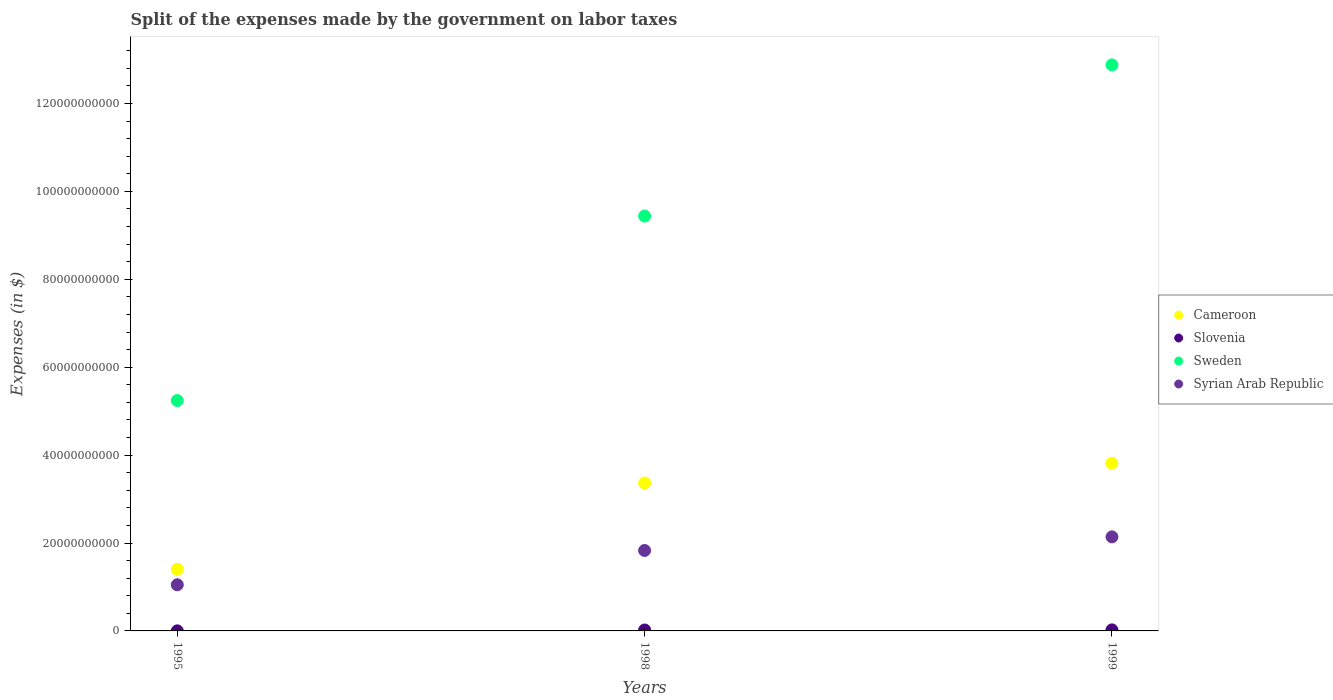How many different coloured dotlines are there?
Your answer should be compact. 4. Is the number of dotlines equal to the number of legend labels?
Your answer should be compact. Yes. What is the expenses made by the government on labor taxes in Cameroon in 1995?
Provide a succinct answer. 1.40e+1. Across all years, what is the maximum expenses made by the government on labor taxes in Cameroon?
Offer a terse response. 3.81e+1. Across all years, what is the minimum expenses made by the government on labor taxes in Cameroon?
Offer a terse response. 1.40e+1. In which year was the expenses made by the government on labor taxes in Slovenia maximum?
Make the answer very short. 1999. In which year was the expenses made by the government on labor taxes in Syrian Arab Republic minimum?
Ensure brevity in your answer.  1995. What is the total expenses made by the government on labor taxes in Slovenia in the graph?
Give a very brief answer. 4.68e+08. What is the difference between the expenses made by the government on labor taxes in Slovenia in 1995 and that in 1999?
Provide a short and direct response. -2.25e+08. What is the difference between the expenses made by the government on labor taxes in Slovenia in 1998 and the expenses made by the government on labor taxes in Sweden in 1999?
Your answer should be compact. -1.29e+11. What is the average expenses made by the government on labor taxes in Sweden per year?
Provide a short and direct response. 9.19e+1. In the year 1998, what is the difference between the expenses made by the government on labor taxes in Sweden and expenses made by the government on labor taxes in Cameroon?
Provide a short and direct response. 6.07e+1. What is the ratio of the expenses made by the government on labor taxes in Syrian Arab Republic in 1995 to that in 1998?
Provide a short and direct response. 0.57. What is the difference between the highest and the second highest expenses made by the government on labor taxes in Syrian Arab Republic?
Offer a very short reply. 3.10e+09. What is the difference between the highest and the lowest expenses made by the government on labor taxes in Sweden?
Offer a terse response. 7.64e+1. In how many years, is the expenses made by the government on labor taxes in Sweden greater than the average expenses made by the government on labor taxes in Sweden taken over all years?
Your answer should be compact. 2. Are the values on the major ticks of Y-axis written in scientific E-notation?
Ensure brevity in your answer.  No. Does the graph contain any zero values?
Your answer should be very brief. No. Does the graph contain grids?
Offer a very short reply. No. How are the legend labels stacked?
Your answer should be very brief. Vertical. What is the title of the graph?
Your answer should be compact. Split of the expenses made by the government on labor taxes. Does "Cabo Verde" appear as one of the legend labels in the graph?
Your answer should be compact. No. What is the label or title of the Y-axis?
Make the answer very short. Expenses (in $). What is the Expenses (in $) in Cameroon in 1995?
Your answer should be compact. 1.40e+1. What is the Expenses (in $) in Slovenia in 1995?
Keep it short and to the point. 1.59e+07. What is the Expenses (in $) in Sweden in 1995?
Offer a terse response. 5.24e+1. What is the Expenses (in $) in Syrian Arab Republic in 1995?
Keep it short and to the point. 1.05e+1. What is the Expenses (in $) of Cameroon in 1998?
Offer a terse response. 3.36e+1. What is the Expenses (in $) in Slovenia in 1998?
Offer a terse response. 2.12e+08. What is the Expenses (in $) of Sweden in 1998?
Your answer should be compact. 9.44e+1. What is the Expenses (in $) of Syrian Arab Republic in 1998?
Your answer should be compact. 1.83e+1. What is the Expenses (in $) of Cameroon in 1999?
Offer a very short reply. 3.81e+1. What is the Expenses (in $) of Slovenia in 1999?
Make the answer very short. 2.40e+08. What is the Expenses (in $) of Sweden in 1999?
Offer a very short reply. 1.29e+11. What is the Expenses (in $) in Syrian Arab Republic in 1999?
Your answer should be very brief. 2.14e+1. Across all years, what is the maximum Expenses (in $) of Cameroon?
Give a very brief answer. 3.81e+1. Across all years, what is the maximum Expenses (in $) of Slovenia?
Provide a short and direct response. 2.40e+08. Across all years, what is the maximum Expenses (in $) of Sweden?
Keep it short and to the point. 1.29e+11. Across all years, what is the maximum Expenses (in $) in Syrian Arab Republic?
Provide a succinct answer. 2.14e+1. Across all years, what is the minimum Expenses (in $) in Cameroon?
Give a very brief answer. 1.40e+1. Across all years, what is the minimum Expenses (in $) in Slovenia?
Keep it short and to the point. 1.59e+07. Across all years, what is the minimum Expenses (in $) of Sweden?
Offer a terse response. 5.24e+1. Across all years, what is the minimum Expenses (in $) in Syrian Arab Republic?
Keep it short and to the point. 1.05e+1. What is the total Expenses (in $) in Cameroon in the graph?
Give a very brief answer. 8.58e+1. What is the total Expenses (in $) in Slovenia in the graph?
Your response must be concise. 4.68e+08. What is the total Expenses (in $) of Sweden in the graph?
Ensure brevity in your answer.  2.76e+11. What is the total Expenses (in $) in Syrian Arab Republic in the graph?
Your answer should be compact. 5.02e+1. What is the difference between the Expenses (in $) of Cameroon in 1995 and that in 1998?
Provide a succinct answer. -1.96e+1. What is the difference between the Expenses (in $) in Slovenia in 1995 and that in 1998?
Offer a terse response. -1.96e+08. What is the difference between the Expenses (in $) of Sweden in 1995 and that in 1998?
Your answer should be very brief. -4.20e+1. What is the difference between the Expenses (in $) of Syrian Arab Republic in 1995 and that in 1998?
Your answer should be compact. -7.80e+09. What is the difference between the Expenses (in $) in Cameroon in 1995 and that in 1999?
Ensure brevity in your answer.  -2.41e+1. What is the difference between the Expenses (in $) in Slovenia in 1995 and that in 1999?
Your answer should be very brief. -2.25e+08. What is the difference between the Expenses (in $) in Sweden in 1995 and that in 1999?
Ensure brevity in your answer.  -7.64e+1. What is the difference between the Expenses (in $) in Syrian Arab Republic in 1995 and that in 1999?
Give a very brief answer. -1.09e+1. What is the difference between the Expenses (in $) of Cameroon in 1998 and that in 1999?
Offer a terse response. -4.49e+09. What is the difference between the Expenses (in $) of Slovenia in 1998 and that in 1999?
Your answer should be very brief. -2.88e+07. What is the difference between the Expenses (in $) of Sweden in 1998 and that in 1999?
Offer a terse response. -3.44e+1. What is the difference between the Expenses (in $) in Syrian Arab Republic in 1998 and that in 1999?
Provide a short and direct response. -3.10e+09. What is the difference between the Expenses (in $) in Cameroon in 1995 and the Expenses (in $) in Slovenia in 1998?
Provide a short and direct response. 1.38e+1. What is the difference between the Expenses (in $) of Cameroon in 1995 and the Expenses (in $) of Sweden in 1998?
Your response must be concise. -8.03e+1. What is the difference between the Expenses (in $) of Cameroon in 1995 and the Expenses (in $) of Syrian Arab Republic in 1998?
Offer a very short reply. -4.25e+09. What is the difference between the Expenses (in $) in Slovenia in 1995 and the Expenses (in $) in Sweden in 1998?
Make the answer very short. -9.44e+1. What is the difference between the Expenses (in $) in Slovenia in 1995 and the Expenses (in $) in Syrian Arab Republic in 1998?
Provide a short and direct response. -1.83e+1. What is the difference between the Expenses (in $) in Sweden in 1995 and the Expenses (in $) in Syrian Arab Republic in 1998?
Ensure brevity in your answer.  3.41e+1. What is the difference between the Expenses (in $) in Cameroon in 1995 and the Expenses (in $) in Slovenia in 1999?
Your response must be concise. 1.38e+1. What is the difference between the Expenses (in $) in Cameroon in 1995 and the Expenses (in $) in Sweden in 1999?
Ensure brevity in your answer.  -1.15e+11. What is the difference between the Expenses (in $) of Cameroon in 1995 and the Expenses (in $) of Syrian Arab Republic in 1999?
Offer a very short reply. -7.35e+09. What is the difference between the Expenses (in $) of Slovenia in 1995 and the Expenses (in $) of Sweden in 1999?
Ensure brevity in your answer.  -1.29e+11. What is the difference between the Expenses (in $) in Slovenia in 1995 and the Expenses (in $) in Syrian Arab Republic in 1999?
Provide a succinct answer. -2.14e+1. What is the difference between the Expenses (in $) of Sweden in 1995 and the Expenses (in $) of Syrian Arab Republic in 1999?
Make the answer very short. 3.10e+1. What is the difference between the Expenses (in $) of Cameroon in 1998 and the Expenses (in $) of Slovenia in 1999?
Provide a short and direct response. 3.34e+1. What is the difference between the Expenses (in $) of Cameroon in 1998 and the Expenses (in $) of Sweden in 1999?
Make the answer very short. -9.51e+1. What is the difference between the Expenses (in $) in Cameroon in 1998 and the Expenses (in $) in Syrian Arab Republic in 1999?
Provide a short and direct response. 1.22e+1. What is the difference between the Expenses (in $) in Slovenia in 1998 and the Expenses (in $) in Sweden in 1999?
Ensure brevity in your answer.  -1.29e+11. What is the difference between the Expenses (in $) in Slovenia in 1998 and the Expenses (in $) in Syrian Arab Republic in 1999?
Provide a short and direct response. -2.12e+1. What is the difference between the Expenses (in $) of Sweden in 1998 and the Expenses (in $) of Syrian Arab Republic in 1999?
Keep it short and to the point. 7.30e+1. What is the average Expenses (in $) in Cameroon per year?
Your answer should be compact. 2.86e+1. What is the average Expenses (in $) of Slovenia per year?
Your answer should be very brief. 1.56e+08. What is the average Expenses (in $) in Sweden per year?
Give a very brief answer. 9.19e+1. What is the average Expenses (in $) of Syrian Arab Republic per year?
Your answer should be very brief. 1.67e+1. In the year 1995, what is the difference between the Expenses (in $) in Cameroon and Expenses (in $) in Slovenia?
Give a very brief answer. 1.40e+1. In the year 1995, what is the difference between the Expenses (in $) of Cameroon and Expenses (in $) of Sweden?
Give a very brief answer. -3.84e+1. In the year 1995, what is the difference between the Expenses (in $) in Cameroon and Expenses (in $) in Syrian Arab Republic?
Provide a succinct answer. 3.55e+09. In the year 1995, what is the difference between the Expenses (in $) in Slovenia and Expenses (in $) in Sweden?
Your answer should be very brief. -5.24e+1. In the year 1995, what is the difference between the Expenses (in $) in Slovenia and Expenses (in $) in Syrian Arab Republic?
Your response must be concise. -1.05e+1. In the year 1995, what is the difference between the Expenses (in $) in Sweden and Expenses (in $) in Syrian Arab Republic?
Keep it short and to the point. 4.19e+1. In the year 1998, what is the difference between the Expenses (in $) of Cameroon and Expenses (in $) of Slovenia?
Provide a short and direct response. 3.34e+1. In the year 1998, what is the difference between the Expenses (in $) in Cameroon and Expenses (in $) in Sweden?
Keep it short and to the point. -6.07e+1. In the year 1998, what is the difference between the Expenses (in $) of Cameroon and Expenses (in $) of Syrian Arab Republic?
Offer a very short reply. 1.54e+1. In the year 1998, what is the difference between the Expenses (in $) of Slovenia and Expenses (in $) of Sweden?
Offer a very short reply. -9.42e+1. In the year 1998, what is the difference between the Expenses (in $) of Slovenia and Expenses (in $) of Syrian Arab Republic?
Offer a very short reply. -1.81e+1. In the year 1998, what is the difference between the Expenses (in $) in Sweden and Expenses (in $) in Syrian Arab Republic?
Provide a short and direct response. 7.61e+1. In the year 1999, what is the difference between the Expenses (in $) of Cameroon and Expenses (in $) of Slovenia?
Your answer should be very brief. 3.79e+1. In the year 1999, what is the difference between the Expenses (in $) in Cameroon and Expenses (in $) in Sweden?
Make the answer very short. -9.06e+1. In the year 1999, what is the difference between the Expenses (in $) in Cameroon and Expenses (in $) in Syrian Arab Republic?
Your answer should be compact. 1.67e+1. In the year 1999, what is the difference between the Expenses (in $) of Slovenia and Expenses (in $) of Sweden?
Provide a short and direct response. -1.29e+11. In the year 1999, what is the difference between the Expenses (in $) of Slovenia and Expenses (in $) of Syrian Arab Republic?
Provide a short and direct response. -2.12e+1. In the year 1999, what is the difference between the Expenses (in $) of Sweden and Expenses (in $) of Syrian Arab Republic?
Ensure brevity in your answer.  1.07e+11. What is the ratio of the Expenses (in $) of Cameroon in 1995 to that in 1998?
Your response must be concise. 0.42. What is the ratio of the Expenses (in $) of Slovenia in 1995 to that in 1998?
Give a very brief answer. 0.07. What is the ratio of the Expenses (in $) in Sweden in 1995 to that in 1998?
Provide a succinct answer. 0.56. What is the ratio of the Expenses (in $) in Syrian Arab Republic in 1995 to that in 1998?
Your answer should be compact. 0.57. What is the ratio of the Expenses (in $) in Cameroon in 1995 to that in 1999?
Keep it short and to the point. 0.37. What is the ratio of the Expenses (in $) of Slovenia in 1995 to that in 1999?
Make the answer very short. 0.07. What is the ratio of the Expenses (in $) of Sweden in 1995 to that in 1999?
Your answer should be compact. 0.41. What is the ratio of the Expenses (in $) in Syrian Arab Republic in 1995 to that in 1999?
Make the answer very short. 0.49. What is the ratio of the Expenses (in $) in Cameroon in 1998 to that in 1999?
Give a very brief answer. 0.88. What is the ratio of the Expenses (in $) in Slovenia in 1998 to that in 1999?
Your answer should be compact. 0.88. What is the ratio of the Expenses (in $) in Sweden in 1998 to that in 1999?
Your answer should be very brief. 0.73. What is the ratio of the Expenses (in $) of Syrian Arab Republic in 1998 to that in 1999?
Your answer should be very brief. 0.86. What is the difference between the highest and the second highest Expenses (in $) in Cameroon?
Ensure brevity in your answer.  4.49e+09. What is the difference between the highest and the second highest Expenses (in $) in Slovenia?
Offer a very short reply. 2.88e+07. What is the difference between the highest and the second highest Expenses (in $) of Sweden?
Keep it short and to the point. 3.44e+1. What is the difference between the highest and the second highest Expenses (in $) in Syrian Arab Republic?
Provide a short and direct response. 3.10e+09. What is the difference between the highest and the lowest Expenses (in $) of Cameroon?
Your response must be concise. 2.41e+1. What is the difference between the highest and the lowest Expenses (in $) of Slovenia?
Offer a very short reply. 2.25e+08. What is the difference between the highest and the lowest Expenses (in $) of Sweden?
Make the answer very short. 7.64e+1. What is the difference between the highest and the lowest Expenses (in $) of Syrian Arab Republic?
Give a very brief answer. 1.09e+1. 